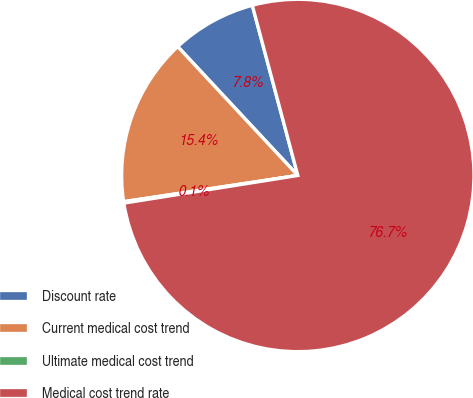Convert chart. <chart><loc_0><loc_0><loc_500><loc_500><pie_chart><fcel>Discount rate<fcel>Current medical cost trend<fcel>Ultimate medical cost trend<fcel>Medical cost trend rate<nl><fcel>7.78%<fcel>15.44%<fcel>0.13%<fcel>76.65%<nl></chart> 